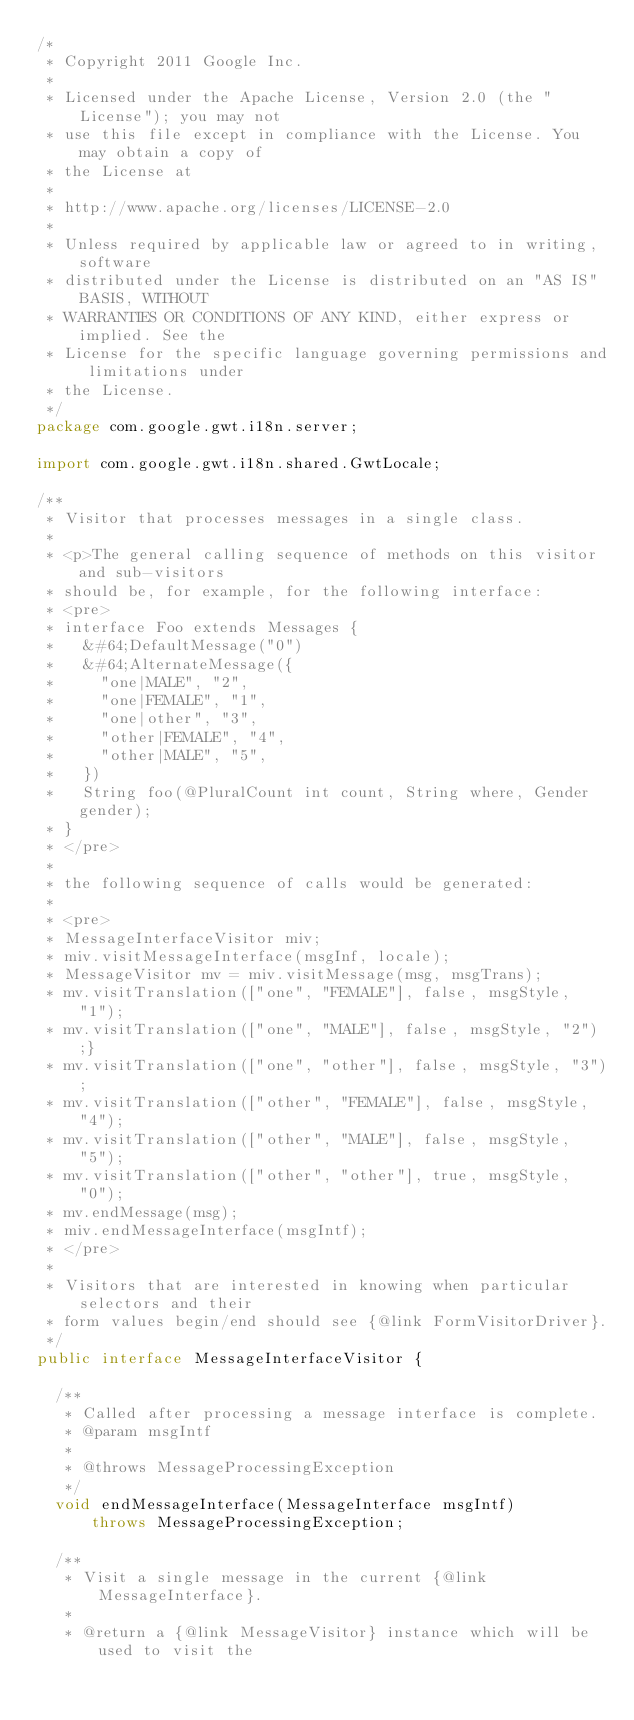<code> <loc_0><loc_0><loc_500><loc_500><_Java_>/*
 * Copyright 2011 Google Inc.
 *
 * Licensed under the Apache License, Version 2.0 (the "License"); you may not
 * use this file except in compliance with the License. You may obtain a copy of
 * the License at
 *
 * http://www.apache.org/licenses/LICENSE-2.0
 *
 * Unless required by applicable law or agreed to in writing, software
 * distributed under the License is distributed on an "AS IS" BASIS, WITHOUT
 * WARRANTIES OR CONDITIONS OF ANY KIND, either express or implied. See the
 * License for the specific language governing permissions and limitations under
 * the License.
 */
package com.google.gwt.i18n.server;

import com.google.gwt.i18n.shared.GwtLocale;

/**
 * Visitor that processes messages in a single class.
 * 
 * <p>The general calling sequence of methods on this visitor and sub-visitors
 * should be, for example, for the following interface:
 * <pre>
 * interface Foo extends Messages {
 *   &#64;DefaultMessage("0")
 *   &#64;AlternateMessage({
 *     "one|MALE", "2",
 *     "one|FEMALE", "1",
 *     "one|other", "3",
 *     "other|FEMALE", "4",
 *     "other|MALE", "5",
 *   })
 *   String foo(@PluralCount int count, String where, Gender gender);
 * }
 * </pre>
 * 
 * the following sequence of calls would be generated:
 * 
 * <pre>
 * MessageInterfaceVisitor miv; 
 * miv.visitMessageInterface(msgInf, locale);
 * MessageVisitor mv = miv.visitMessage(msg, msgTrans);
 * mv.visitTranslation(["one", "FEMALE"], false, msgStyle, "1");
 * mv.visitTranslation(["one", "MALE"], false, msgStyle, "2");}
 * mv.visitTranslation(["one", "other"], false, msgStyle, "3");
 * mv.visitTranslation(["other", "FEMALE"], false, msgStyle, "4");
 * mv.visitTranslation(["other", "MALE"], false, msgStyle, "5");
 * mv.visitTranslation(["other", "other"], true, msgStyle, "0");
 * mv.endMessage(msg);
 * miv.endMessageInterface(msgIntf);
 * </pre>
 * 
 * Visitors that are interested in knowing when particular selectors and their
 * form values begin/end should see {@link FormVisitorDriver}.
 */
public interface MessageInterfaceVisitor {

  /**
   * Called after processing a message interface is complete.
   * @param msgIntf
   * 
   * @throws MessageProcessingException
   */
  void endMessageInterface(MessageInterface msgIntf)
      throws MessageProcessingException;

  /**
   * Visit a single message in the current {@link MessageInterface}.
   * 
   * @return a {@link MessageVisitor} instance which will be used to visit the</code> 